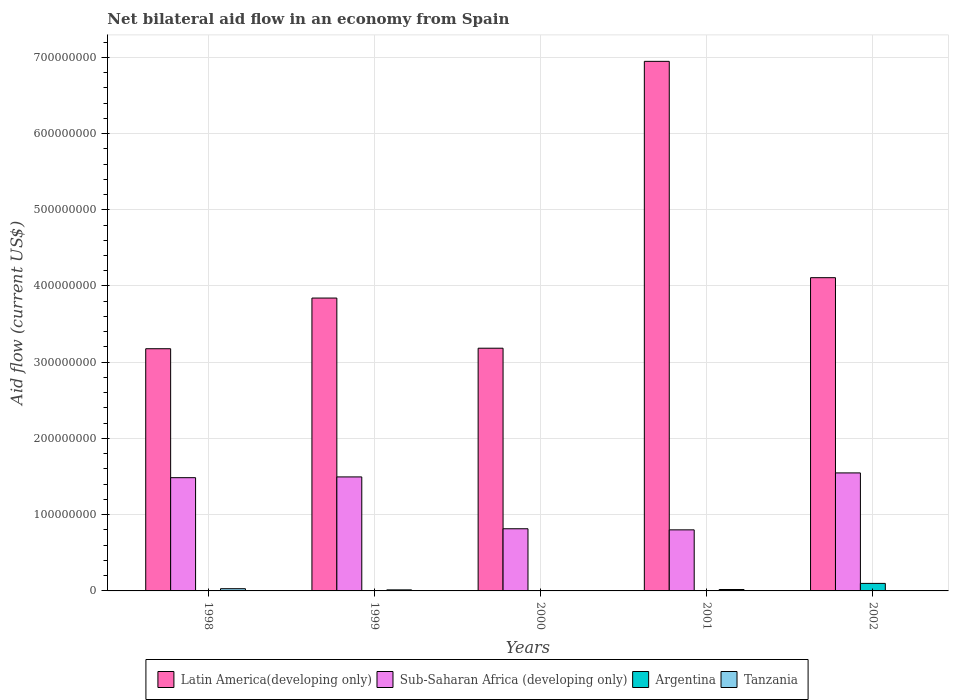How many different coloured bars are there?
Your response must be concise. 4. Are the number of bars on each tick of the X-axis equal?
Your response must be concise. No. How many bars are there on the 5th tick from the left?
Offer a very short reply. 4. How many bars are there on the 5th tick from the right?
Offer a terse response. 3. What is the net bilateral aid flow in Sub-Saharan Africa (developing only) in 2000?
Your response must be concise. 8.16e+07. Across all years, what is the maximum net bilateral aid flow in Argentina?
Offer a very short reply. 9.86e+06. Across all years, what is the minimum net bilateral aid flow in Sub-Saharan Africa (developing only)?
Make the answer very short. 8.01e+07. What is the total net bilateral aid flow in Latin America(developing only) in the graph?
Provide a short and direct response. 2.13e+09. What is the difference between the net bilateral aid flow in Sub-Saharan Africa (developing only) in 1999 and that in 2000?
Ensure brevity in your answer.  6.80e+07. What is the difference between the net bilateral aid flow in Tanzania in 2000 and the net bilateral aid flow in Latin America(developing only) in 2001?
Provide a short and direct response. -6.94e+08. What is the average net bilateral aid flow in Tanzania per year?
Keep it short and to the point. 1.35e+06. In the year 2002, what is the difference between the net bilateral aid flow in Argentina and net bilateral aid flow in Sub-Saharan Africa (developing only)?
Provide a short and direct response. -1.45e+08. In how many years, is the net bilateral aid flow in Sub-Saharan Africa (developing only) greater than 680000000 US$?
Your response must be concise. 0. What is the ratio of the net bilateral aid flow in Sub-Saharan Africa (developing only) in 1998 to that in 2002?
Make the answer very short. 0.96. What is the difference between the highest and the second highest net bilateral aid flow in Tanzania?
Your answer should be compact. 1.05e+06. What is the difference between the highest and the lowest net bilateral aid flow in Tanzania?
Provide a succinct answer. 2.62e+06. Is it the case that in every year, the sum of the net bilateral aid flow in Argentina and net bilateral aid flow in Sub-Saharan Africa (developing only) is greater than the net bilateral aid flow in Latin America(developing only)?
Provide a succinct answer. No. Are all the bars in the graph horizontal?
Ensure brevity in your answer.  No. What is the difference between two consecutive major ticks on the Y-axis?
Ensure brevity in your answer.  1.00e+08. Does the graph contain any zero values?
Your response must be concise. Yes. Does the graph contain grids?
Give a very brief answer. Yes. How many legend labels are there?
Your response must be concise. 4. How are the legend labels stacked?
Your answer should be compact. Horizontal. What is the title of the graph?
Make the answer very short. Net bilateral aid flow in an economy from Spain. What is the label or title of the X-axis?
Your answer should be very brief. Years. What is the Aid flow (current US$) of Latin America(developing only) in 1998?
Offer a terse response. 3.18e+08. What is the Aid flow (current US$) of Sub-Saharan Africa (developing only) in 1998?
Offer a terse response. 1.49e+08. What is the Aid flow (current US$) in Argentina in 1998?
Your response must be concise. 0. What is the Aid flow (current US$) in Tanzania in 1998?
Offer a very short reply. 2.91e+06. What is the Aid flow (current US$) of Latin America(developing only) in 1999?
Offer a very short reply. 3.84e+08. What is the Aid flow (current US$) of Sub-Saharan Africa (developing only) in 1999?
Your answer should be compact. 1.50e+08. What is the Aid flow (current US$) of Argentina in 1999?
Provide a succinct answer. 0. What is the Aid flow (current US$) in Tanzania in 1999?
Offer a terse response. 1.38e+06. What is the Aid flow (current US$) in Latin America(developing only) in 2000?
Your answer should be very brief. 3.18e+08. What is the Aid flow (current US$) of Sub-Saharan Africa (developing only) in 2000?
Give a very brief answer. 8.16e+07. What is the Aid flow (current US$) of Tanzania in 2000?
Offer a terse response. 2.90e+05. What is the Aid flow (current US$) of Latin America(developing only) in 2001?
Give a very brief answer. 6.95e+08. What is the Aid flow (current US$) of Sub-Saharan Africa (developing only) in 2001?
Make the answer very short. 8.01e+07. What is the Aid flow (current US$) of Tanzania in 2001?
Your response must be concise. 1.86e+06. What is the Aid flow (current US$) in Latin America(developing only) in 2002?
Provide a succinct answer. 4.11e+08. What is the Aid flow (current US$) of Sub-Saharan Africa (developing only) in 2002?
Your answer should be compact. 1.55e+08. What is the Aid flow (current US$) of Argentina in 2002?
Ensure brevity in your answer.  9.86e+06. What is the Aid flow (current US$) in Tanzania in 2002?
Offer a very short reply. 3.10e+05. Across all years, what is the maximum Aid flow (current US$) of Latin America(developing only)?
Keep it short and to the point. 6.95e+08. Across all years, what is the maximum Aid flow (current US$) of Sub-Saharan Africa (developing only)?
Your answer should be very brief. 1.55e+08. Across all years, what is the maximum Aid flow (current US$) of Argentina?
Offer a very short reply. 9.86e+06. Across all years, what is the maximum Aid flow (current US$) in Tanzania?
Your answer should be very brief. 2.91e+06. Across all years, what is the minimum Aid flow (current US$) in Latin America(developing only)?
Provide a succinct answer. 3.18e+08. Across all years, what is the minimum Aid flow (current US$) in Sub-Saharan Africa (developing only)?
Your answer should be compact. 8.01e+07. Across all years, what is the minimum Aid flow (current US$) in Argentina?
Your answer should be compact. 0. Across all years, what is the minimum Aid flow (current US$) of Tanzania?
Your answer should be very brief. 2.90e+05. What is the total Aid flow (current US$) in Latin America(developing only) in the graph?
Your answer should be compact. 2.13e+09. What is the total Aid flow (current US$) in Sub-Saharan Africa (developing only) in the graph?
Give a very brief answer. 6.15e+08. What is the total Aid flow (current US$) in Argentina in the graph?
Ensure brevity in your answer.  9.86e+06. What is the total Aid flow (current US$) of Tanzania in the graph?
Your answer should be very brief. 6.75e+06. What is the difference between the Aid flow (current US$) in Latin America(developing only) in 1998 and that in 1999?
Ensure brevity in your answer.  -6.65e+07. What is the difference between the Aid flow (current US$) in Tanzania in 1998 and that in 1999?
Your response must be concise. 1.53e+06. What is the difference between the Aid flow (current US$) in Latin America(developing only) in 1998 and that in 2000?
Give a very brief answer. -6.90e+05. What is the difference between the Aid flow (current US$) in Sub-Saharan Africa (developing only) in 1998 and that in 2000?
Your answer should be very brief. 6.70e+07. What is the difference between the Aid flow (current US$) of Tanzania in 1998 and that in 2000?
Offer a terse response. 2.62e+06. What is the difference between the Aid flow (current US$) of Latin America(developing only) in 1998 and that in 2001?
Give a very brief answer. -3.77e+08. What is the difference between the Aid flow (current US$) in Sub-Saharan Africa (developing only) in 1998 and that in 2001?
Your response must be concise. 6.84e+07. What is the difference between the Aid flow (current US$) in Tanzania in 1998 and that in 2001?
Make the answer very short. 1.05e+06. What is the difference between the Aid flow (current US$) in Latin America(developing only) in 1998 and that in 2002?
Keep it short and to the point. -9.32e+07. What is the difference between the Aid flow (current US$) in Sub-Saharan Africa (developing only) in 1998 and that in 2002?
Your answer should be very brief. -6.26e+06. What is the difference between the Aid flow (current US$) of Tanzania in 1998 and that in 2002?
Provide a short and direct response. 2.60e+06. What is the difference between the Aid flow (current US$) in Latin America(developing only) in 1999 and that in 2000?
Make the answer very short. 6.58e+07. What is the difference between the Aid flow (current US$) of Sub-Saharan Africa (developing only) in 1999 and that in 2000?
Your response must be concise. 6.80e+07. What is the difference between the Aid flow (current US$) in Tanzania in 1999 and that in 2000?
Offer a terse response. 1.09e+06. What is the difference between the Aid flow (current US$) of Latin America(developing only) in 1999 and that in 2001?
Give a very brief answer. -3.10e+08. What is the difference between the Aid flow (current US$) in Sub-Saharan Africa (developing only) in 1999 and that in 2001?
Make the answer very short. 6.94e+07. What is the difference between the Aid flow (current US$) of Tanzania in 1999 and that in 2001?
Give a very brief answer. -4.80e+05. What is the difference between the Aid flow (current US$) of Latin America(developing only) in 1999 and that in 2002?
Your answer should be compact. -2.67e+07. What is the difference between the Aid flow (current US$) of Sub-Saharan Africa (developing only) in 1999 and that in 2002?
Provide a succinct answer. -5.26e+06. What is the difference between the Aid flow (current US$) of Tanzania in 1999 and that in 2002?
Provide a short and direct response. 1.07e+06. What is the difference between the Aid flow (current US$) in Latin America(developing only) in 2000 and that in 2001?
Your answer should be very brief. -3.76e+08. What is the difference between the Aid flow (current US$) in Sub-Saharan Africa (developing only) in 2000 and that in 2001?
Your answer should be very brief. 1.44e+06. What is the difference between the Aid flow (current US$) in Tanzania in 2000 and that in 2001?
Give a very brief answer. -1.57e+06. What is the difference between the Aid flow (current US$) in Latin America(developing only) in 2000 and that in 2002?
Give a very brief answer. -9.25e+07. What is the difference between the Aid flow (current US$) of Sub-Saharan Africa (developing only) in 2000 and that in 2002?
Make the answer very short. -7.33e+07. What is the difference between the Aid flow (current US$) of Latin America(developing only) in 2001 and that in 2002?
Give a very brief answer. 2.84e+08. What is the difference between the Aid flow (current US$) of Sub-Saharan Africa (developing only) in 2001 and that in 2002?
Give a very brief answer. -7.47e+07. What is the difference between the Aid flow (current US$) of Tanzania in 2001 and that in 2002?
Your answer should be very brief. 1.55e+06. What is the difference between the Aid flow (current US$) in Latin America(developing only) in 1998 and the Aid flow (current US$) in Sub-Saharan Africa (developing only) in 1999?
Your answer should be compact. 1.68e+08. What is the difference between the Aid flow (current US$) of Latin America(developing only) in 1998 and the Aid flow (current US$) of Tanzania in 1999?
Offer a very short reply. 3.16e+08. What is the difference between the Aid flow (current US$) in Sub-Saharan Africa (developing only) in 1998 and the Aid flow (current US$) in Tanzania in 1999?
Give a very brief answer. 1.47e+08. What is the difference between the Aid flow (current US$) in Latin America(developing only) in 1998 and the Aid flow (current US$) in Sub-Saharan Africa (developing only) in 2000?
Offer a very short reply. 2.36e+08. What is the difference between the Aid flow (current US$) of Latin America(developing only) in 1998 and the Aid flow (current US$) of Tanzania in 2000?
Ensure brevity in your answer.  3.17e+08. What is the difference between the Aid flow (current US$) in Sub-Saharan Africa (developing only) in 1998 and the Aid flow (current US$) in Tanzania in 2000?
Your response must be concise. 1.48e+08. What is the difference between the Aid flow (current US$) in Latin America(developing only) in 1998 and the Aid flow (current US$) in Sub-Saharan Africa (developing only) in 2001?
Your response must be concise. 2.38e+08. What is the difference between the Aid flow (current US$) in Latin America(developing only) in 1998 and the Aid flow (current US$) in Tanzania in 2001?
Offer a very short reply. 3.16e+08. What is the difference between the Aid flow (current US$) of Sub-Saharan Africa (developing only) in 1998 and the Aid flow (current US$) of Tanzania in 2001?
Your answer should be very brief. 1.47e+08. What is the difference between the Aid flow (current US$) of Latin America(developing only) in 1998 and the Aid flow (current US$) of Sub-Saharan Africa (developing only) in 2002?
Give a very brief answer. 1.63e+08. What is the difference between the Aid flow (current US$) of Latin America(developing only) in 1998 and the Aid flow (current US$) of Argentina in 2002?
Provide a short and direct response. 3.08e+08. What is the difference between the Aid flow (current US$) in Latin America(developing only) in 1998 and the Aid flow (current US$) in Tanzania in 2002?
Make the answer very short. 3.17e+08. What is the difference between the Aid flow (current US$) of Sub-Saharan Africa (developing only) in 1998 and the Aid flow (current US$) of Argentina in 2002?
Your answer should be compact. 1.39e+08. What is the difference between the Aid flow (current US$) of Sub-Saharan Africa (developing only) in 1998 and the Aid flow (current US$) of Tanzania in 2002?
Your answer should be compact. 1.48e+08. What is the difference between the Aid flow (current US$) in Latin America(developing only) in 1999 and the Aid flow (current US$) in Sub-Saharan Africa (developing only) in 2000?
Your answer should be compact. 3.03e+08. What is the difference between the Aid flow (current US$) in Latin America(developing only) in 1999 and the Aid flow (current US$) in Tanzania in 2000?
Provide a short and direct response. 3.84e+08. What is the difference between the Aid flow (current US$) of Sub-Saharan Africa (developing only) in 1999 and the Aid flow (current US$) of Tanzania in 2000?
Make the answer very short. 1.49e+08. What is the difference between the Aid flow (current US$) of Latin America(developing only) in 1999 and the Aid flow (current US$) of Sub-Saharan Africa (developing only) in 2001?
Your answer should be very brief. 3.04e+08. What is the difference between the Aid flow (current US$) of Latin America(developing only) in 1999 and the Aid flow (current US$) of Tanzania in 2001?
Offer a terse response. 3.82e+08. What is the difference between the Aid flow (current US$) of Sub-Saharan Africa (developing only) in 1999 and the Aid flow (current US$) of Tanzania in 2001?
Provide a succinct answer. 1.48e+08. What is the difference between the Aid flow (current US$) in Latin America(developing only) in 1999 and the Aid flow (current US$) in Sub-Saharan Africa (developing only) in 2002?
Your answer should be very brief. 2.29e+08. What is the difference between the Aid flow (current US$) in Latin America(developing only) in 1999 and the Aid flow (current US$) in Argentina in 2002?
Your answer should be compact. 3.74e+08. What is the difference between the Aid flow (current US$) of Latin America(developing only) in 1999 and the Aid flow (current US$) of Tanzania in 2002?
Ensure brevity in your answer.  3.84e+08. What is the difference between the Aid flow (current US$) of Sub-Saharan Africa (developing only) in 1999 and the Aid flow (current US$) of Argentina in 2002?
Your response must be concise. 1.40e+08. What is the difference between the Aid flow (current US$) of Sub-Saharan Africa (developing only) in 1999 and the Aid flow (current US$) of Tanzania in 2002?
Provide a succinct answer. 1.49e+08. What is the difference between the Aid flow (current US$) in Latin America(developing only) in 2000 and the Aid flow (current US$) in Sub-Saharan Africa (developing only) in 2001?
Offer a terse response. 2.38e+08. What is the difference between the Aid flow (current US$) of Latin America(developing only) in 2000 and the Aid flow (current US$) of Tanzania in 2001?
Provide a succinct answer. 3.17e+08. What is the difference between the Aid flow (current US$) in Sub-Saharan Africa (developing only) in 2000 and the Aid flow (current US$) in Tanzania in 2001?
Your answer should be very brief. 7.97e+07. What is the difference between the Aid flow (current US$) in Latin America(developing only) in 2000 and the Aid flow (current US$) in Sub-Saharan Africa (developing only) in 2002?
Provide a short and direct response. 1.64e+08. What is the difference between the Aid flow (current US$) of Latin America(developing only) in 2000 and the Aid flow (current US$) of Argentina in 2002?
Provide a succinct answer. 3.09e+08. What is the difference between the Aid flow (current US$) of Latin America(developing only) in 2000 and the Aid flow (current US$) of Tanzania in 2002?
Your answer should be compact. 3.18e+08. What is the difference between the Aid flow (current US$) in Sub-Saharan Africa (developing only) in 2000 and the Aid flow (current US$) in Argentina in 2002?
Provide a short and direct response. 7.17e+07. What is the difference between the Aid flow (current US$) in Sub-Saharan Africa (developing only) in 2000 and the Aid flow (current US$) in Tanzania in 2002?
Keep it short and to the point. 8.12e+07. What is the difference between the Aid flow (current US$) in Latin America(developing only) in 2001 and the Aid flow (current US$) in Sub-Saharan Africa (developing only) in 2002?
Make the answer very short. 5.40e+08. What is the difference between the Aid flow (current US$) in Latin America(developing only) in 2001 and the Aid flow (current US$) in Argentina in 2002?
Offer a terse response. 6.85e+08. What is the difference between the Aid flow (current US$) in Latin America(developing only) in 2001 and the Aid flow (current US$) in Tanzania in 2002?
Offer a terse response. 6.94e+08. What is the difference between the Aid flow (current US$) of Sub-Saharan Africa (developing only) in 2001 and the Aid flow (current US$) of Argentina in 2002?
Your answer should be compact. 7.02e+07. What is the difference between the Aid flow (current US$) of Sub-Saharan Africa (developing only) in 2001 and the Aid flow (current US$) of Tanzania in 2002?
Your answer should be very brief. 7.98e+07. What is the average Aid flow (current US$) in Latin America(developing only) per year?
Your answer should be very brief. 4.25e+08. What is the average Aid flow (current US$) in Sub-Saharan Africa (developing only) per year?
Your response must be concise. 1.23e+08. What is the average Aid flow (current US$) of Argentina per year?
Offer a very short reply. 1.97e+06. What is the average Aid flow (current US$) in Tanzania per year?
Offer a terse response. 1.35e+06. In the year 1998, what is the difference between the Aid flow (current US$) in Latin America(developing only) and Aid flow (current US$) in Sub-Saharan Africa (developing only)?
Provide a short and direct response. 1.69e+08. In the year 1998, what is the difference between the Aid flow (current US$) in Latin America(developing only) and Aid flow (current US$) in Tanzania?
Give a very brief answer. 3.15e+08. In the year 1998, what is the difference between the Aid flow (current US$) in Sub-Saharan Africa (developing only) and Aid flow (current US$) in Tanzania?
Keep it short and to the point. 1.46e+08. In the year 1999, what is the difference between the Aid flow (current US$) of Latin America(developing only) and Aid flow (current US$) of Sub-Saharan Africa (developing only)?
Provide a succinct answer. 2.35e+08. In the year 1999, what is the difference between the Aid flow (current US$) of Latin America(developing only) and Aid flow (current US$) of Tanzania?
Keep it short and to the point. 3.83e+08. In the year 1999, what is the difference between the Aid flow (current US$) in Sub-Saharan Africa (developing only) and Aid flow (current US$) in Tanzania?
Provide a succinct answer. 1.48e+08. In the year 2000, what is the difference between the Aid flow (current US$) of Latin America(developing only) and Aid flow (current US$) of Sub-Saharan Africa (developing only)?
Your answer should be very brief. 2.37e+08. In the year 2000, what is the difference between the Aid flow (current US$) of Latin America(developing only) and Aid flow (current US$) of Tanzania?
Offer a terse response. 3.18e+08. In the year 2000, what is the difference between the Aid flow (current US$) of Sub-Saharan Africa (developing only) and Aid flow (current US$) of Tanzania?
Offer a terse response. 8.13e+07. In the year 2001, what is the difference between the Aid flow (current US$) of Latin America(developing only) and Aid flow (current US$) of Sub-Saharan Africa (developing only)?
Your response must be concise. 6.15e+08. In the year 2001, what is the difference between the Aid flow (current US$) in Latin America(developing only) and Aid flow (current US$) in Tanzania?
Your answer should be very brief. 6.93e+08. In the year 2001, what is the difference between the Aid flow (current US$) of Sub-Saharan Africa (developing only) and Aid flow (current US$) of Tanzania?
Provide a short and direct response. 7.82e+07. In the year 2002, what is the difference between the Aid flow (current US$) of Latin America(developing only) and Aid flow (current US$) of Sub-Saharan Africa (developing only)?
Your answer should be compact. 2.56e+08. In the year 2002, what is the difference between the Aid flow (current US$) of Latin America(developing only) and Aid flow (current US$) of Argentina?
Ensure brevity in your answer.  4.01e+08. In the year 2002, what is the difference between the Aid flow (current US$) in Latin America(developing only) and Aid flow (current US$) in Tanzania?
Provide a short and direct response. 4.11e+08. In the year 2002, what is the difference between the Aid flow (current US$) in Sub-Saharan Africa (developing only) and Aid flow (current US$) in Argentina?
Your response must be concise. 1.45e+08. In the year 2002, what is the difference between the Aid flow (current US$) of Sub-Saharan Africa (developing only) and Aid flow (current US$) of Tanzania?
Your answer should be compact. 1.54e+08. In the year 2002, what is the difference between the Aid flow (current US$) in Argentina and Aid flow (current US$) in Tanzania?
Your answer should be very brief. 9.55e+06. What is the ratio of the Aid flow (current US$) in Latin America(developing only) in 1998 to that in 1999?
Offer a terse response. 0.83. What is the ratio of the Aid flow (current US$) in Tanzania in 1998 to that in 1999?
Keep it short and to the point. 2.11. What is the ratio of the Aid flow (current US$) of Latin America(developing only) in 1998 to that in 2000?
Your answer should be compact. 1. What is the ratio of the Aid flow (current US$) in Sub-Saharan Africa (developing only) in 1998 to that in 2000?
Offer a very short reply. 1.82. What is the ratio of the Aid flow (current US$) in Tanzania in 1998 to that in 2000?
Your answer should be compact. 10.03. What is the ratio of the Aid flow (current US$) in Latin America(developing only) in 1998 to that in 2001?
Your answer should be compact. 0.46. What is the ratio of the Aid flow (current US$) of Sub-Saharan Africa (developing only) in 1998 to that in 2001?
Your answer should be compact. 1.85. What is the ratio of the Aid flow (current US$) of Tanzania in 1998 to that in 2001?
Ensure brevity in your answer.  1.56. What is the ratio of the Aid flow (current US$) of Latin America(developing only) in 1998 to that in 2002?
Your response must be concise. 0.77. What is the ratio of the Aid flow (current US$) of Sub-Saharan Africa (developing only) in 1998 to that in 2002?
Your answer should be compact. 0.96. What is the ratio of the Aid flow (current US$) in Tanzania in 1998 to that in 2002?
Provide a short and direct response. 9.39. What is the ratio of the Aid flow (current US$) of Latin America(developing only) in 1999 to that in 2000?
Keep it short and to the point. 1.21. What is the ratio of the Aid flow (current US$) in Sub-Saharan Africa (developing only) in 1999 to that in 2000?
Your response must be concise. 1.83. What is the ratio of the Aid flow (current US$) of Tanzania in 1999 to that in 2000?
Give a very brief answer. 4.76. What is the ratio of the Aid flow (current US$) of Latin America(developing only) in 1999 to that in 2001?
Keep it short and to the point. 0.55. What is the ratio of the Aid flow (current US$) in Sub-Saharan Africa (developing only) in 1999 to that in 2001?
Your response must be concise. 1.87. What is the ratio of the Aid flow (current US$) of Tanzania in 1999 to that in 2001?
Ensure brevity in your answer.  0.74. What is the ratio of the Aid flow (current US$) in Latin America(developing only) in 1999 to that in 2002?
Your answer should be very brief. 0.93. What is the ratio of the Aid flow (current US$) in Tanzania in 1999 to that in 2002?
Give a very brief answer. 4.45. What is the ratio of the Aid flow (current US$) of Latin America(developing only) in 2000 to that in 2001?
Your response must be concise. 0.46. What is the ratio of the Aid flow (current US$) in Sub-Saharan Africa (developing only) in 2000 to that in 2001?
Your answer should be very brief. 1.02. What is the ratio of the Aid flow (current US$) in Tanzania in 2000 to that in 2001?
Provide a short and direct response. 0.16. What is the ratio of the Aid flow (current US$) of Latin America(developing only) in 2000 to that in 2002?
Provide a short and direct response. 0.77. What is the ratio of the Aid flow (current US$) of Sub-Saharan Africa (developing only) in 2000 to that in 2002?
Make the answer very short. 0.53. What is the ratio of the Aid flow (current US$) of Tanzania in 2000 to that in 2002?
Your answer should be compact. 0.94. What is the ratio of the Aid flow (current US$) of Latin America(developing only) in 2001 to that in 2002?
Provide a short and direct response. 1.69. What is the ratio of the Aid flow (current US$) of Sub-Saharan Africa (developing only) in 2001 to that in 2002?
Your answer should be compact. 0.52. What is the difference between the highest and the second highest Aid flow (current US$) of Latin America(developing only)?
Give a very brief answer. 2.84e+08. What is the difference between the highest and the second highest Aid flow (current US$) of Sub-Saharan Africa (developing only)?
Make the answer very short. 5.26e+06. What is the difference between the highest and the second highest Aid flow (current US$) in Tanzania?
Make the answer very short. 1.05e+06. What is the difference between the highest and the lowest Aid flow (current US$) in Latin America(developing only)?
Provide a short and direct response. 3.77e+08. What is the difference between the highest and the lowest Aid flow (current US$) in Sub-Saharan Africa (developing only)?
Offer a very short reply. 7.47e+07. What is the difference between the highest and the lowest Aid flow (current US$) in Argentina?
Keep it short and to the point. 9.86e+06. What is the difference between the highest and the lowest Aid flow (current US$) in Tanzania?
Your answer should be very brief. 2.62e+06. 